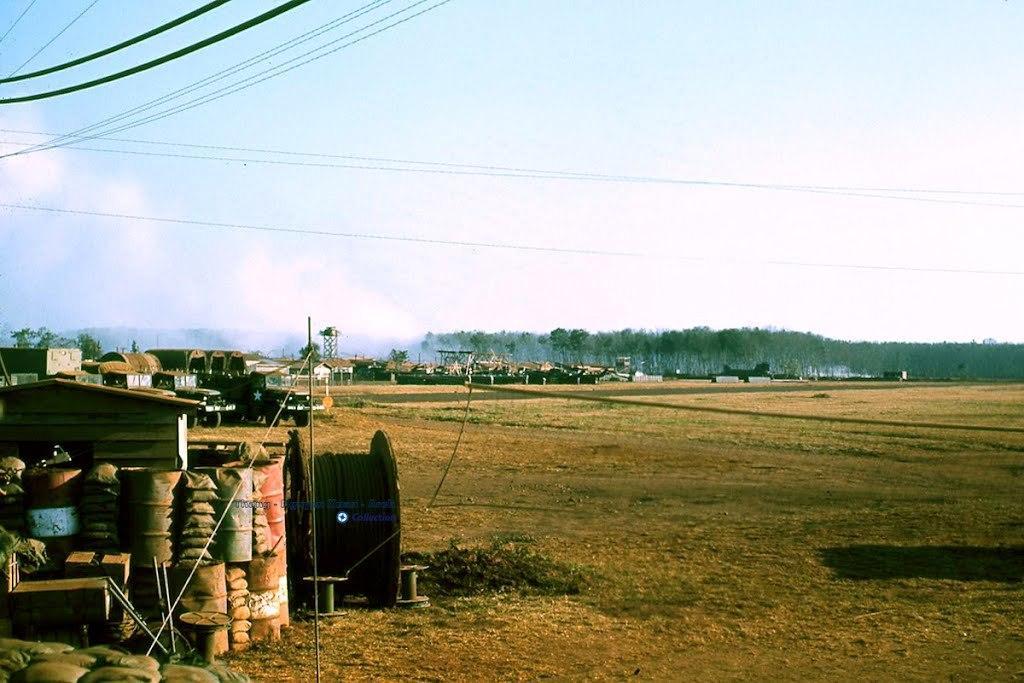Please provide a concise description of this image. In this picture we can see a new, wheel, oil barrels and some objects. Behind the wheel there are vehicles, houses, trees, and the sky. In front of the wheel there are cables. 